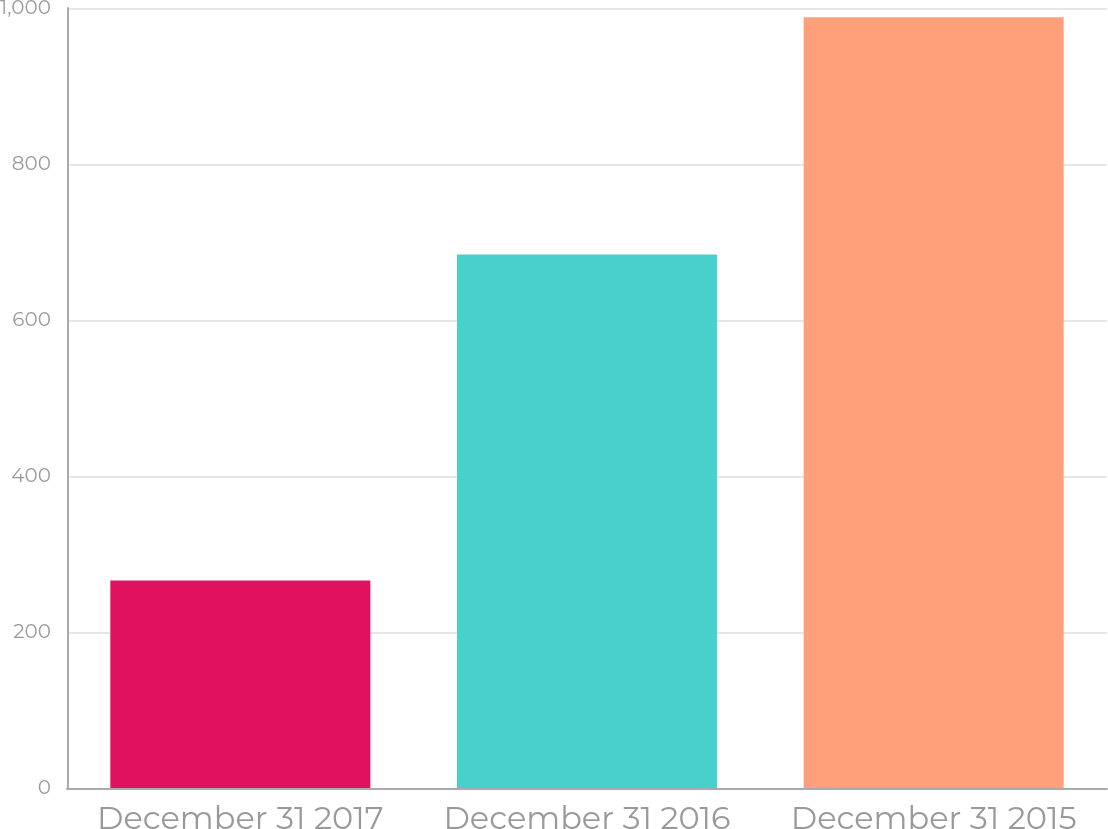<chart> <loc_0><loc_0><loc_500><loc_500><bar_chart><fcel>December 31 2017<fcel>December 31 2016<fcel>December 31 2015<nl><fcel>266<fcel>684<fcel>988<nl></chart> 